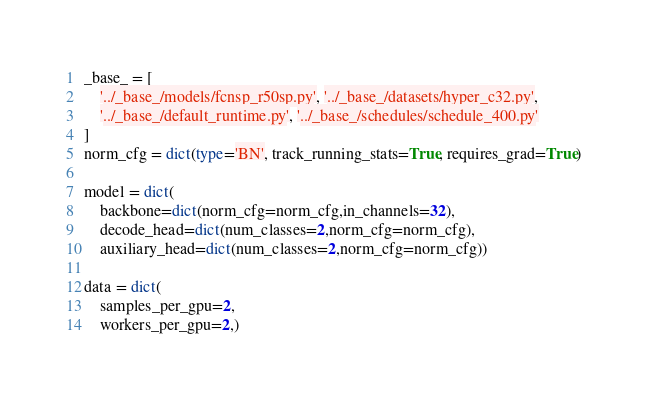Convert code to text. <code><loc_0><loc_0><loc_500><loc_500><_Python_>_base_ = [
    '../_base_/models/fcnsp_r50sp.py', '../_base_/datasets/hyper_c32.py',
    '../_base_/default_runtime.py', '../_base_/schedules/schedule_400.py'
]
norm_cfg = dict(type='BN', track_running_stats=True, requires_grad=True)

model = dict(
    backbone=dict(norm_cfg=norm_cfg,in_channels=32),
    decode_head=dict(num_classes=2,norm_cfg=norm_cfg),
    auxiliary_head=dict(num_classes=2,norm_cfg=norm_cfg))

data = dict(
    samples_per_gpu=2,
    workers_per_gpu=2,)</code> 